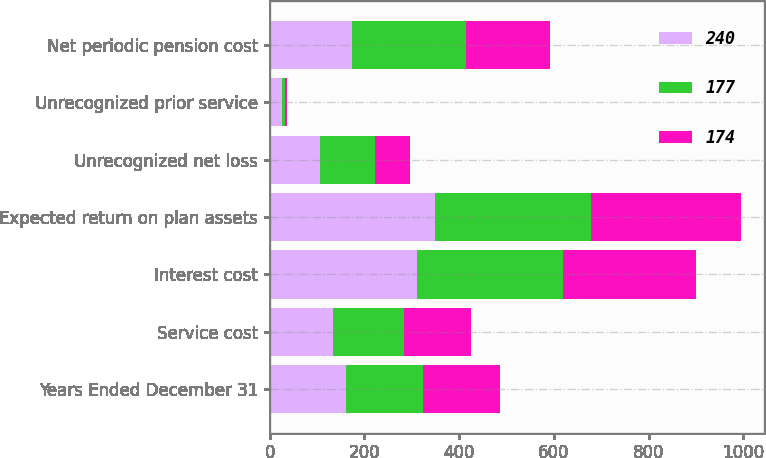Convert chart. <chart><loc_0><loc_0><loc_500><loc_500><stacked_bar_chart><ecel><fcel>Years Ended December 31<fcel>Service cost<fcel>Interest cost<fcel>Expected return on plan assets<fcel>Unrecognized net loss<fcel>Unrecognized prior service<fcel>Net periodic pension cost<nl><fcel>240<fcel>162<fcel>133<fcel>311<fcel>350<fcel>107<fcel>27<fcel>174<nl><fcel>177<fcel>162<fcel>150<fcel>309<fcel>329<fcel>115<fcel>5<fcel>240<nl><fcel>174<fcel>162<fcel>142<fcel>280<fcel>315<fcel>75<fcel>5<fcel>177<nl></chart> 